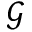<formula> <loc_0><loc_0><loc_500><loc_500>\mathcal { G }</formula> 